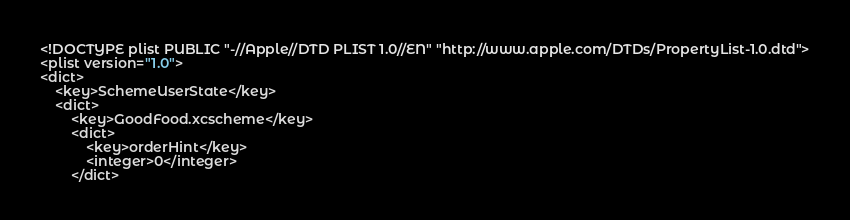<code> <loc_0><loc_0><loc_500><loc_500><_XML_><!DOCTYPE plist PUBLIC "-//Apple//DTD PLIST 1.0//EN" "http://www.apple.com/DTDs/PropertyList-1.0.dtd">
<plist version="1.0">
<dict>
	<key>SchemeUserState</key>
	<dict>
		<key>GoodFood.xcscheme</key>
		<dict>
			<key>orderHint</key>
			<integer>0</integer>
		</dict></code> 